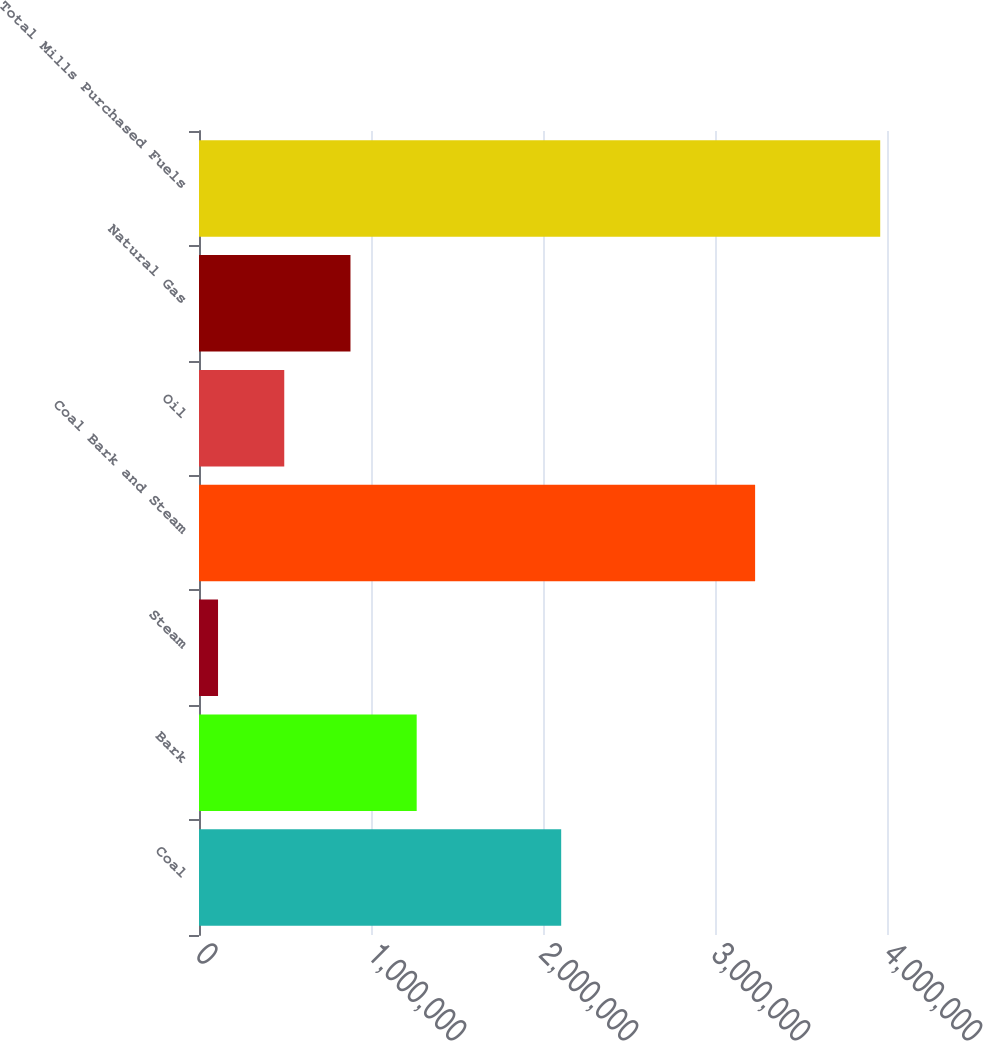Convert chart to OTSL. <chart><loc_0><loc_0><loc_500><loc_500><bar_chart><fcel>Coal<fcel>Bark<fcel>Steam<fcel>Coal Bark and Steam<fcel>Oil<fcel>Natural Gas<fcel>Total Mills Purchased Fuels<nl><fcel>2.10575e+06<fcel>1.26564e+06<fcel>110684<fcel>3.23321e+06<fcel>495669<fcel>880654<fcel>3.96053e+06<nl></chart> 